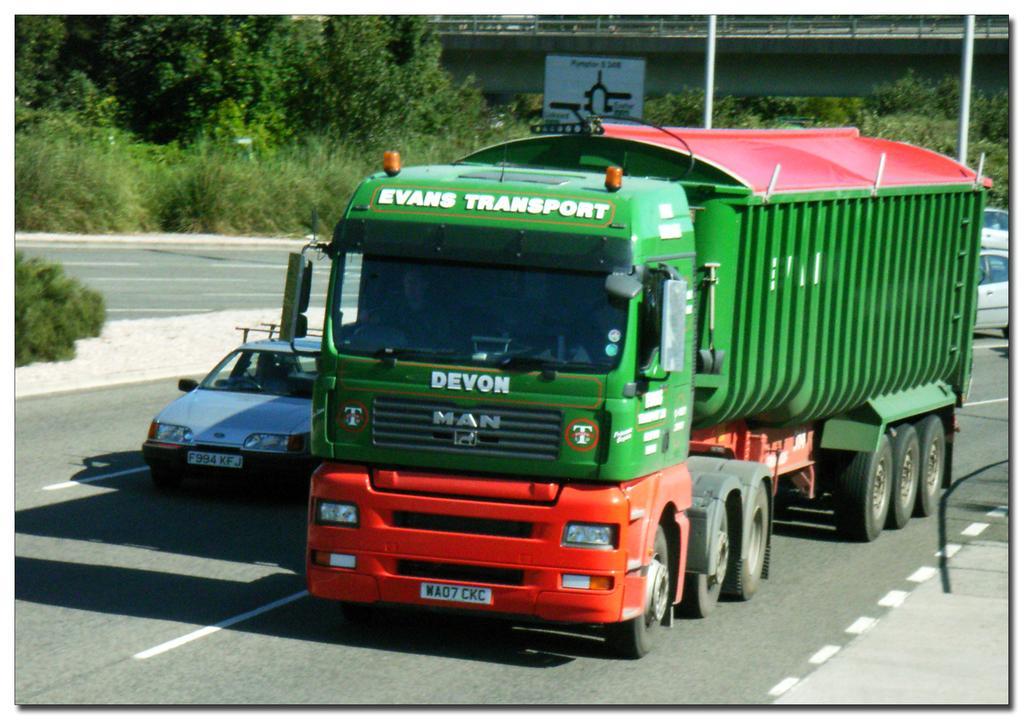Please provide a concise description of this image. On the left there are trees right a car and a truck are moving on the roads. 